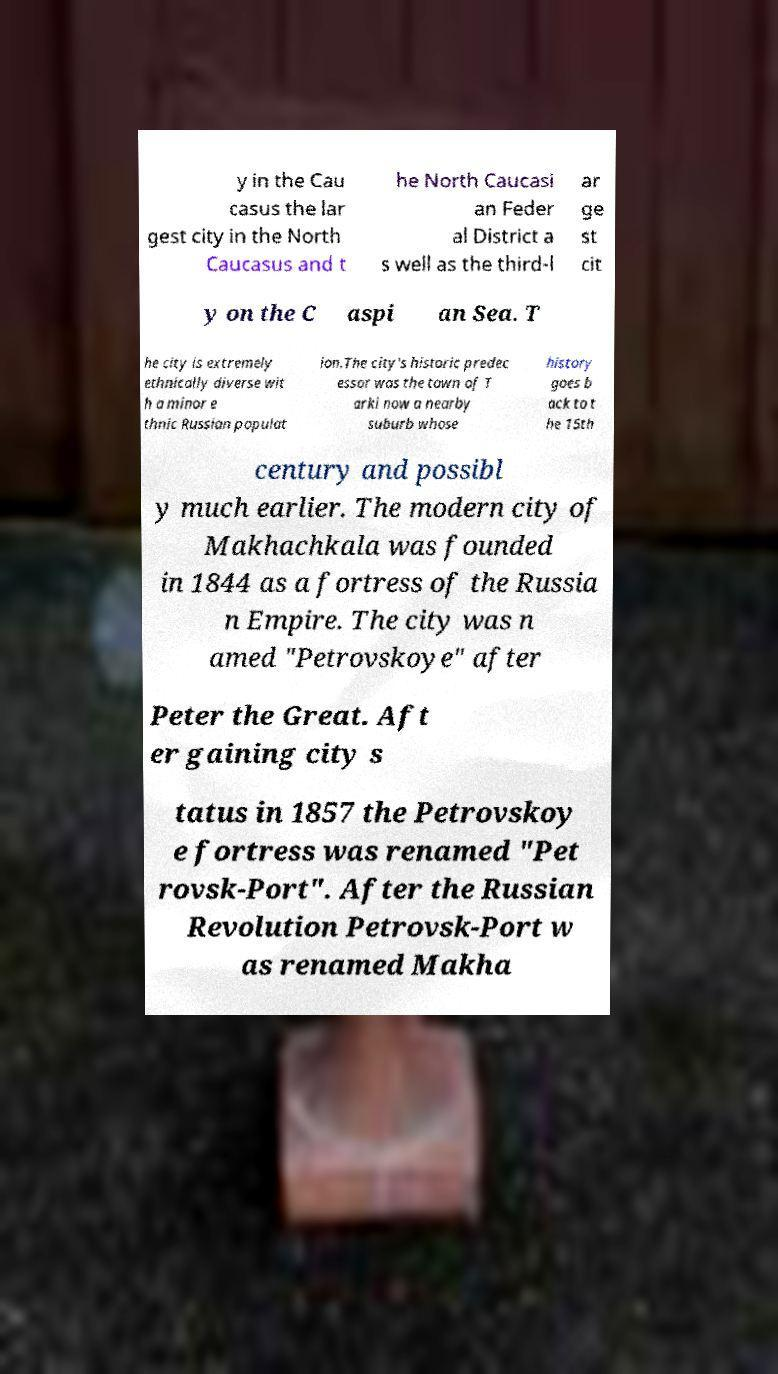Could you extract and type out the text from this image? y in the Cau casus the lar gest city in the North Caucasus and t he North Caucasi an Feder al District a s well as the third-l ar ge st cit y on the C aspi an Sea. T he city is extremely ethnically diverse wit h a minor e thnic Russian populat ion.The city's historic predec essor was the town of T arki now a nearby suburb whose history goes b ack to t he 15th century and possibl y much earlier. The modern city of Makhachkala was founded in 1844 as a fortress of the Russia n Empire. The city was n amed "Petrovskoye" after Peter the Great. Aft er gaining city s tatus in 1857 the Petrovskoy e fortress was renamed "Pet rovsk-Port". After the Russian Revolution Petrovsk-Port w as renamed Makha 